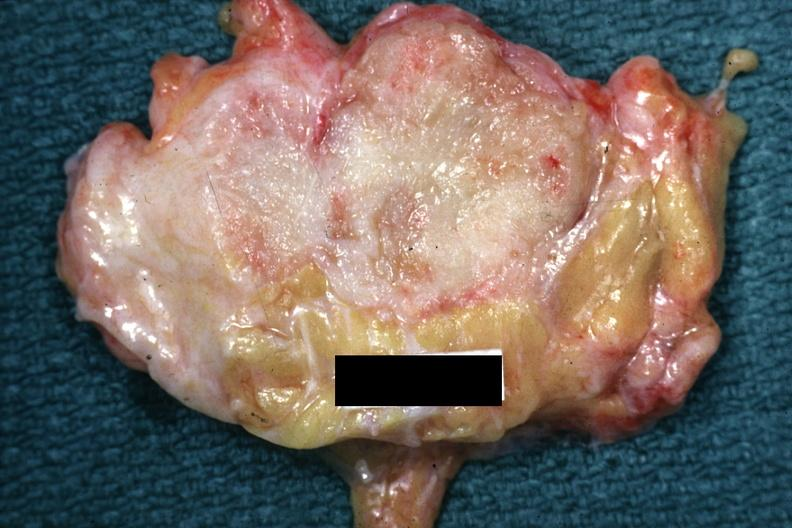what is labeled cystosarcoma?
Answer the question using a single word or phrase. Good example of a breast carcinoma, slide 